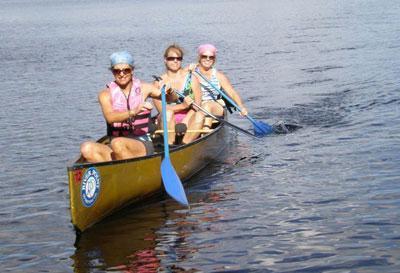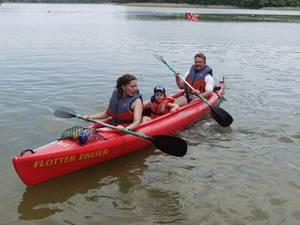The first image is the image on the left, the second image is the image on the right. Assess this claim about the two images: "There is a child sitting between 2 adults in one of the images.". Correct or not? Answer yes or no. Yes. The first image is the image on the left, the second image is the image on the right. Given the left and right images, does the statement "Each canoe has three people sitting in them and at least two of those people have an oar." hold true? Answer yes or no. Yes. 